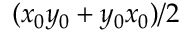Convert formula to latex. <formula><loc_0><loc_0><loc_500><loc_500>( x _ { 0 } y _ { 0 } + y _ { 0 } x _ { 0 } ) / 2</formula> 